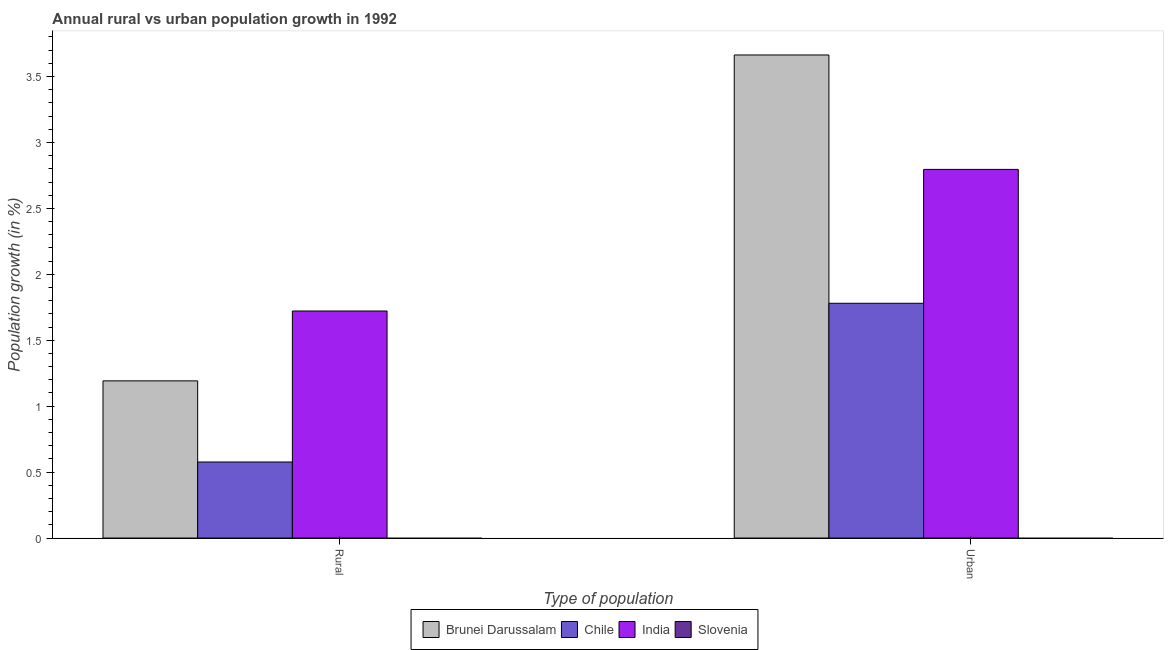How many groups of bars are there?
Give a very brief answer. 2. Are the number of bars per tick equal to the number of legend labels?
Your answer should be very brief. No. What is the label of the 1st group of bars from the left?
Provide a short and direct response. Rural. What is the rural population growth in Chile?
Provide a short and direct response. 0.58. Across all countries, what is the maximum urban population growth?
Offer a very short reply. 3.66. In which country was the urban population growth maximum?
Ensure brevity in your answer.  Brunei Darussalam. What is the total urban population growth in the graph?
Give a very brief answer. 8.24. What is the difference between the urban population growth in Chile and that in India?
Your answer should be compact. -1.02. What is the difference between the urban population growth in India and the rural population growth in Slovenia?
Keep it short and to the point. 2.8. What is the average rural population growth per country?
Make the answer very short. 0.87. What is the difference between the rural population growth and urban population growth in India?
Make the answer very short. -1.07. In how many countries, is the rural population growth greater than 2.6 %?
Keep it short and to the point. 0. What is the ratio of the rural population growth in Brunei Darussalam to that in India?
Keep it short and to the point. 0.69. Are all the bars in the graph horizontal?
Provide a short and direct response. No. How many countries are there in the graph?
Your answer should be very brief. 4. What is the difference between two consecutive major ticks on the Y-axis?
Your answer should be very brief. 0.5. Are the values on the major ticks of Y-axis written in scientific E-notation?
Ensure brevity in your answer.  No. Where does the legend appear in the graph?
Your response must be concise. Bottom center. How are the legend labels stacked?
Provide a short and direct response. Horizontal. What is the title of the graph?
Provide a succinct answer. Annual rural vs urban population growth in 1992. Does "Arab World" appear as one of the legend labels in the graph?
Offer a terse response. No. What is the label or title of the X-axis?
Provide a succinct answer. Type of population. What is the label or title of the Y-axis?
Give a very brief answer. Population growth (in %). What is the Population growth (in %) of Brunei Darussalam in Rural?
Offer a very short reply. 1.19. What is the Population growth (in %) of Chile in Rural?
Ensure brevity in your answer.  0.58. What is the Population growth (in %) of India in Rural?
Your answer should be compact. 1.72. What is the Population growth (in %) of Slovenia in Rural?
Keep it short and to the point. 0. What is the Population growth (in %) of Brunei Darussalam in Urban ?
Offer a terse response. 3.66. What is the Population growth (in %) in Chile in Urban ?
Your response must be concise. 1.78. What is the Population growth (in %) in India in Urban ?
Make the answer very short. 2.8. What is the Population growth (in %) of Slovenia in Urban ?
Your answer should be very brief. 0. Across all Type of population, what is the maximum Population growth (in %) in Brunei Darussalam?
Give a very brief answer. 3.66. Across all Type of population, what is the maximum Population growth (in %) of Chile?
Your answer should be compact. 1.78. Across all Type of population, what is the maximum Population growth (in %) in India?
Provide a succinct answer. 2.8. Across all Type of population, what is the minimum Population growth (in %) of Brunei Darussalam?
Provide a short and direct response. 1.19. Across all Type of population, what is the minimum Population growth (in %) in Chile?
Keep it short and to the point. 0.58. Across all Type of population, what is the minimum Population growth (in %) of India?
Offer a terse response. 1.72. What is the total Population growth (in %) of Brunei Darussalam in the graph?
Provide a short and direct response. 4.86. What is the total Population growth (in %) of Chile in the graph?
Make the answer very short. 2.36. What is the total Population growth (in %) in India in the graph?
Your answer should be compact. 4.52. What is the total Population growth (in %) of Slovenia in the graph?
Your answer should be compact. 0. What is the difference between the Population growth (in %) of Brunei Darussalam in Rural and that in Urban ?
Give a very brief answer. -2.47. What is the difference between the Population growth (in %) in Chile in Rural and that in Urban ?
Make the answer very short. -1.2. What is the difference between the Population growth (in %) of India in Rural and that in Urban ?
Make the answer very short. -1.07. What is the difference between the Population growth (in %) in Brunei Darussalam in Rural and the Population growth (in %) in Chile in Urban?
Ensure brevity in your answer.  -0.59. What is the difference between the Population growth (in %) in Brunei Darussalam in Rural and the Population growth (in %) in India in Urban?
Provide a succinct answer. -1.6. What is the difference between the Population growth (in %) of Chile in Rural and the Population growth (in %) of India in Urban?
Give a very brief answer. -2.22. What is the average Population growth (in %) in Brunei Darussalam per Type of population?
Your answer should be very brief. 2.43. What is the average Population growth (in %) in Chile per Type of population?
Keep it short and to the point. 1.18. What is the average Population growth (in %) in India per Type of population?
Ensure brevity in your answer.  2.26. What is the difference between the Population growth (in %) of Brunei Darussalam and Population growth (in %) of Chile in Rural?
Offer a very short reply. 0.62. What is the difference between the Population growth (in %) in Brunei Darussalam and Population growth (in %) in India in Rural?
Ensure brevity in your answer.  -0.53. What is the difference between the Population growth (in %) of Chile and Population growth (in %) of India in Rural?
Your response must be concise. -1.15. What is the difference between the Population growth (in %) in Brunei Darussalam and Population growth (in %) in Chile in Urban ?
Ensure brevity in your answer.  1.88. What is the difference between the Population growth (in %) in Brunei Darussalam and Population growth (in %) in India in Urban ?
Provide a succinct answer. 0.87. What is the difference between the Population growth (in %) in Chile and Population growth (in %) in India in Urban ?
Your answer should be compact. -1.02. What is the ratio of the Population growth (in %) of Brunei Darussalam in Rural to that in Urban ?
Your response must be concise. 0.33. What is the ratio of the Population growth (in %) of Chile in Rural to that in Urban ?
Your answer should be very brief. 0.32. What is the ratio of the Population growth (in %) in India in Rural to that in Urban ?
Make the answer very short. 0.62. What is the difference between the highest and the second highest Population growth (in %) in Brunei Darussalam?
Your response must be concise. 2.47. What is the difference between the highest and the second highest Population growth (in %) in Chile?
Provide a succinct answer. 1.2. What is the difference between the highest and the second highest Population growth (in %) of India?
Offer a very short reply. 1.07. What is the difference between the highest and the lowest Population growth (in %) in Brunei Darussalam?
Offer a terse response. 2.47. What is the difference between the highest and the lowest Population growth (in %) of Chile?
Keep it short and to the point. 1.2. What is the difference between the highest and the lowest Population growth (in %) in India?
Give a very brief answer. 1.07. 